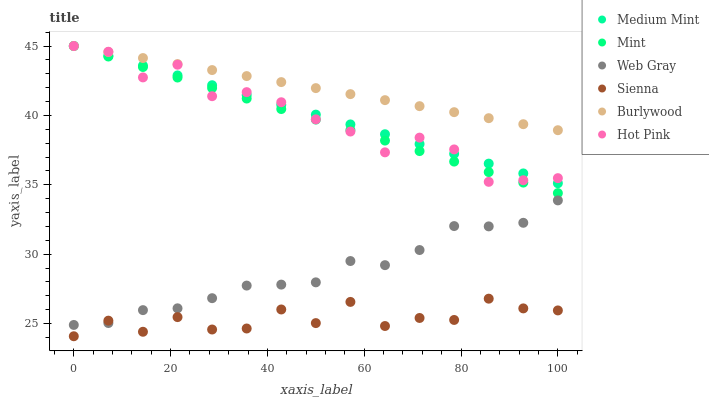Does Sienna have the minimum area under the curve?
Answer yes or no. Yes. Does Burlywood have the maximum area under the curve?
Answer yes or no. Yes. Does Web Gray have the minimum area under the curve?
Answer yes or no. No. Does Web Gray have the maximum area under the curve?
Answer yes or no. No. Is Burlywood the smoothest?
Answer yes or no. Yes. Is Sienna the roughest?
Answer yes or no. Yes. Is Web Gray the smoothest?
Answer yes or no. No. Is Web Gray the roughest?
Answer yes or no. No. Does Sienna have the lowest value?
Answer yes or no. Yes. Does Web Gray have the lowest value?
Answer yes or no. No. Does Mint have the highest value?
Answer yes or no. Yes. Does Web Gray have the highest value?
Answer yes or no. No. Is Web Gray less than Burlywood?
Answer yes or no. Yes. Is Mint greater than Web Gray?
Answer yes or no. Yes. Does Mint intersect Medium Mint?
Answer yes or no. Yes. Is Mint less than Medium Mint?
Answer yes or no. No. Is Mint greater than Medium Mint?
Answer yes or no. No. Does Web Gray intersect Burlywood?
Answer yes or no. No. 